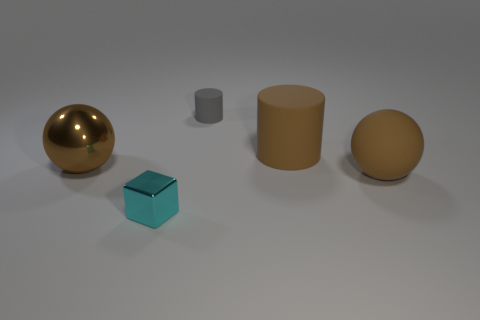Add 4 large purple rubber cylinders. How many objects exist? 9 Subtract all cubes. How many objects are left? 4 Subtract all red cylinders. Subtract all gray matte objects. How many objects are left? 4 Add 2 brown rubber cylinders. How many brown rubber cylinders are left? 3 Add 2 tiny cyan cubes. How many tiny cyan cubes exist? 3 Subtract 0 blue cubes. How many objects are left? 5 